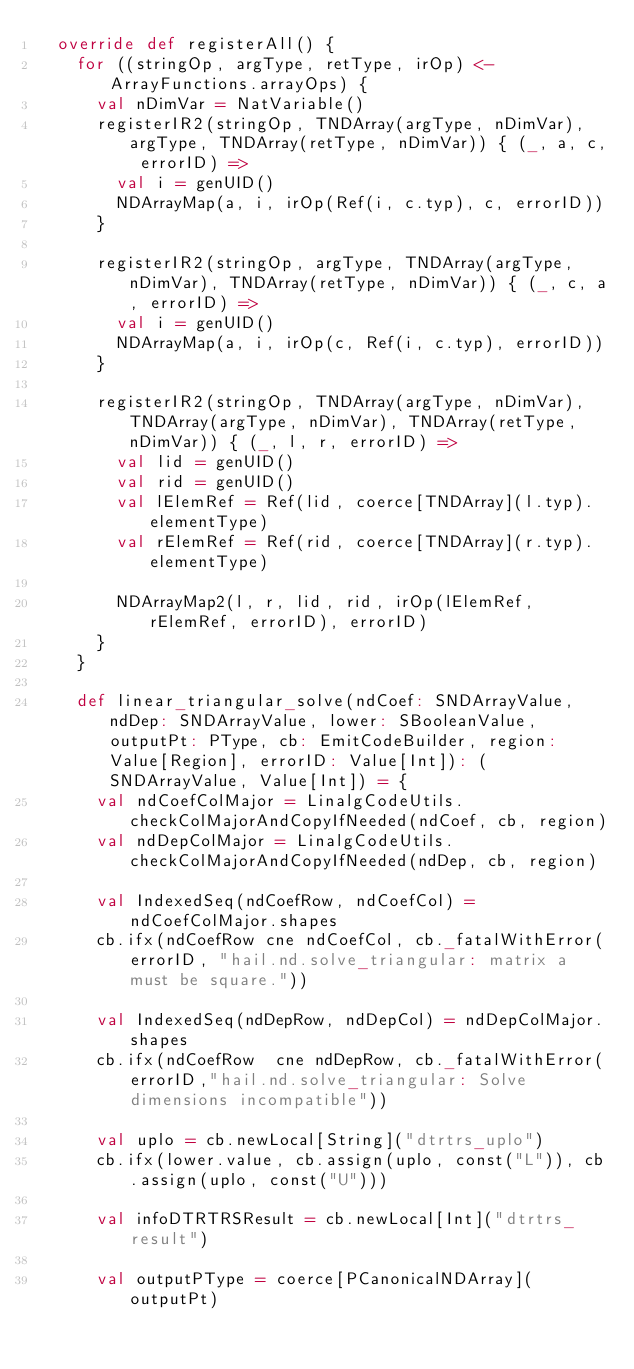Convert code to text. <code><loc_0><loc_0><loc_500><loc_500><_Scala_>  override def registerAll() {
    for ((stringOp, argType, retType, irOp) <- ArrayFunctions.arrayOps) {
      val nDimVar = NatVariable()
      registerIR2(stringOp, TNDArray(argType, nDimVar), argType, TNDArray(retType, nDimVar)) { (_, a, c, errorID) =>
        val i = genUID()
        NDArrayMap(a, i, irOp(Ref(i, c.typ), c, errorID))
      }

      registerIR2(stringOp, argType, TNDArray(argType, nDimVar), TNDArray(retType, nDimVar)) { (_, c, a, errorID) =>
        val i = genUID()
        NDArrayMap(a, i, irOp(c, Ref(i, c.typ), errorID))
      }

      registerIR2(stringOp, TNDArray(argType, nDimVar), TNDArray(argType, nDimVar), TNDArray(retType, nDimVar)) { (_, l, r, errorID) =>
        val lid = genUID()
        val rid = genUID()
        val lElemRef = Ref(lid, coerce[TNDArray](l.typ).elementType)
        val rElemRef = Ref(rid, coerce[TNDArray](r.typ).elementType)

        NDArrayMap2(l, r, lid, rid, irOp(lElemRef, rElemRef, errorID), errorID)
      }
    }

    def linear_triangular_solve(ndCoef: SNDArrayValue, ndDep: SNDArrayValue, lower: SBooleanValue, outputPt: PType, cb: EmitCodeBuilder, region: Value[Region], errorID: Value[Int]): (SNDArrayValue, Value[Int]) = {
      val ndCoefColMajor = LinalgCodeUtils.checkColMajorAndCopyIfNeeded(ndCoef, cb, region)
      val ndDepColMajor = LinalgCodeUtils.checkColMajorAndCopyIfNeeded(ndDep, cb, region)

      val IndexedSeq(ndCoefRow, ndCoefCol) = ndCoefColMajor.shapes
      cb.ifx(ndCoefRow cne ndCoefCol, cb._fatalWithError(errorID, "hail.nd.solve_triangular: matrix a must be square."))

      val IndexedSeq(ndDepRow, ndDepCol) = ndDepColMajor.shapes
      cb.ifx(ndCoefRow  cne ndDepRow, cb._fatalWithError(errorID,"hail.nd.solve_triangular: Solve dimensions incompatible"))

      val uplo = cb.newLocal[String]("dtrtrs_uplo")
      cb.ifx(lower.value, cb.assign(uplo, const("L")), cb.assign(uplo, const("U")))

      val infoDTRTRSResult = cb.newLocal[Int]("dtrtrs_result")

      val outputPType = coerce[PCanonicalNDArray](outputPt)</code> 